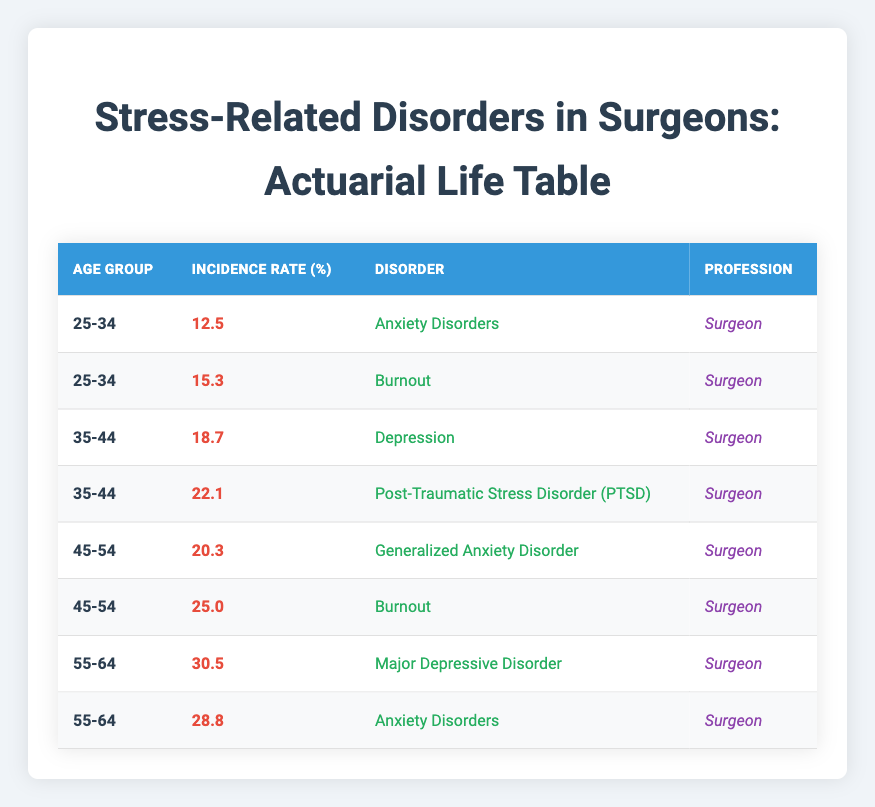What is the incidence rate of Anxiety Disorders for surgeons aged 25-34? The table shows that the incidence rate of Anxiety Disorders for the age group 25-34 is 12.5%.
Answer: 12.5% Which disorder has the highest incidence rate among surgeons aged 55-64? By looking at the data for the age group 55-64, Major Depressive Disorder has the highest incidence rate at 30.5% compared to Anxiety Disorders at 28.8%.
Answer: Major Depressive Disorder What is the total incidence rate of Burnout for surgeons across all age groups? The table lists Burnout incidences: 15.3% for ages 25-34 and 25.0% for ages 45-54. Adding these gives: 15.3 + 25.0 = 40.3%.
Answer: 40.3% Is the incidence rate of Depression higher for surgeons aged 35-44 compared to Generalized Anxiety Disorder for ages 45-54? The incidence rate for Depression among surgeons aged 35-44 is 18.7%, while Generalized Anxiety Disorder for ages 45-54 has an incidence rate of 20.3%. Since 20.3% is greater than 18.7%, the statement is false.
Answer: No What is the average incidence rate of Anxiety Disorders for surgeons aged 25-34 and 55-64? The incidence rate of Anxiety Disorders for ages 25-34 is 12.5%, and for ages 55-64, it is 28.8%. Adding these gives 12.5 + 28.8 = 41.3%, and then dividing by 2 gives an average of 20.65%.
Answer: 20.65% 